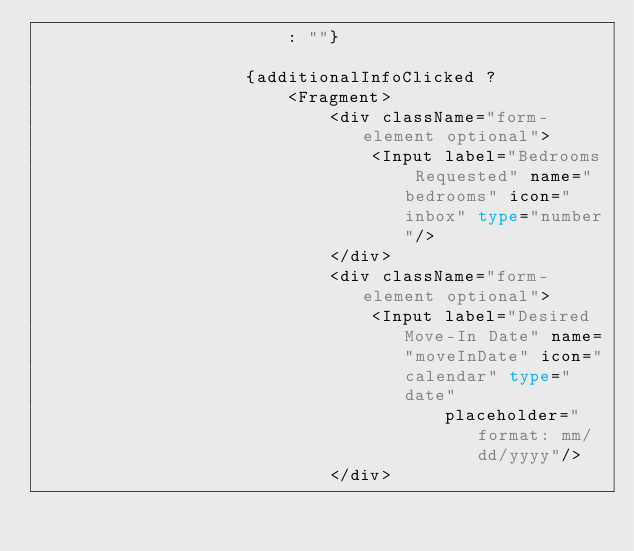Convert code to text. <code><loc_0><loc_0><loc_500><loc_500><_TypeScript_>                        : ""}

                    {additionalInfoClicked ?
                        <Fragment>
                            <div className="form-element optional">
                                <Input label="Bedrooms Requested" name="bedrooms" icon="inbox" type="number"/>
                            </div>
                            <div className="form-element optional">
                                <Input label="Desired Move-In Date" name="moveInDate" icon="calendar" type="date"
                                       placeholder="format: mm/dd/yyyy"/>
                            </div></code> 